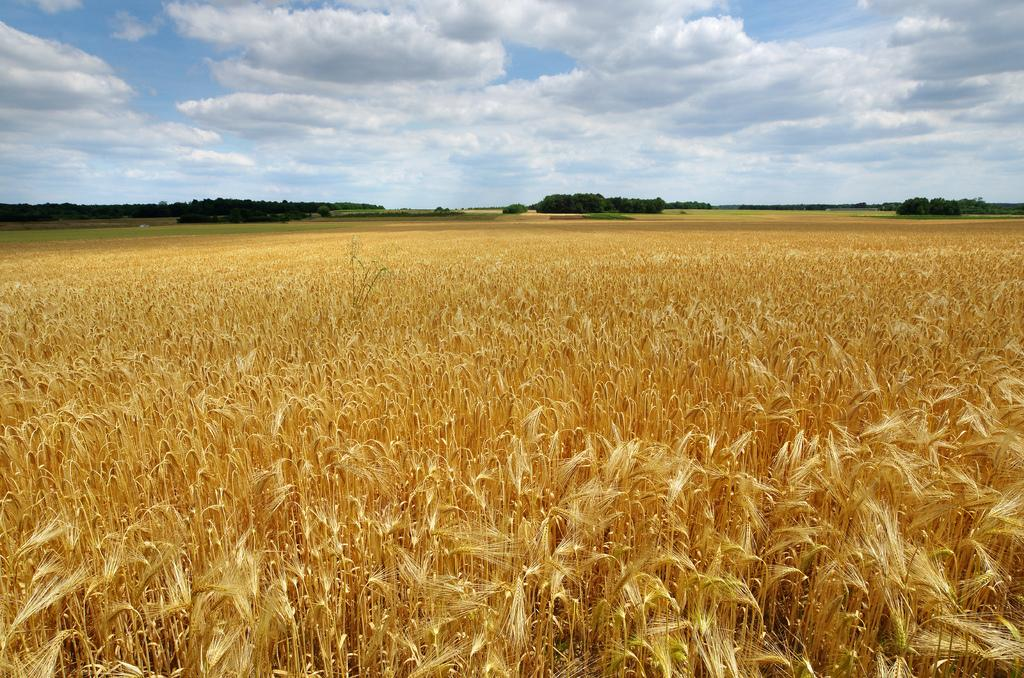What type of living organisms can be seen in the image? Plants can be seen in the image. What is the color of the plants in the image? The plants are brown in color. Where are the plants located in the image? The plants are on the ground. What can be seen in the background of the image? Trees and the sky are visible in the background of the image. What is the color of the trees in the image? The trees are green in color. What type of jeans is the wren wearing in the image? There is no wren or jeans present in the image. 